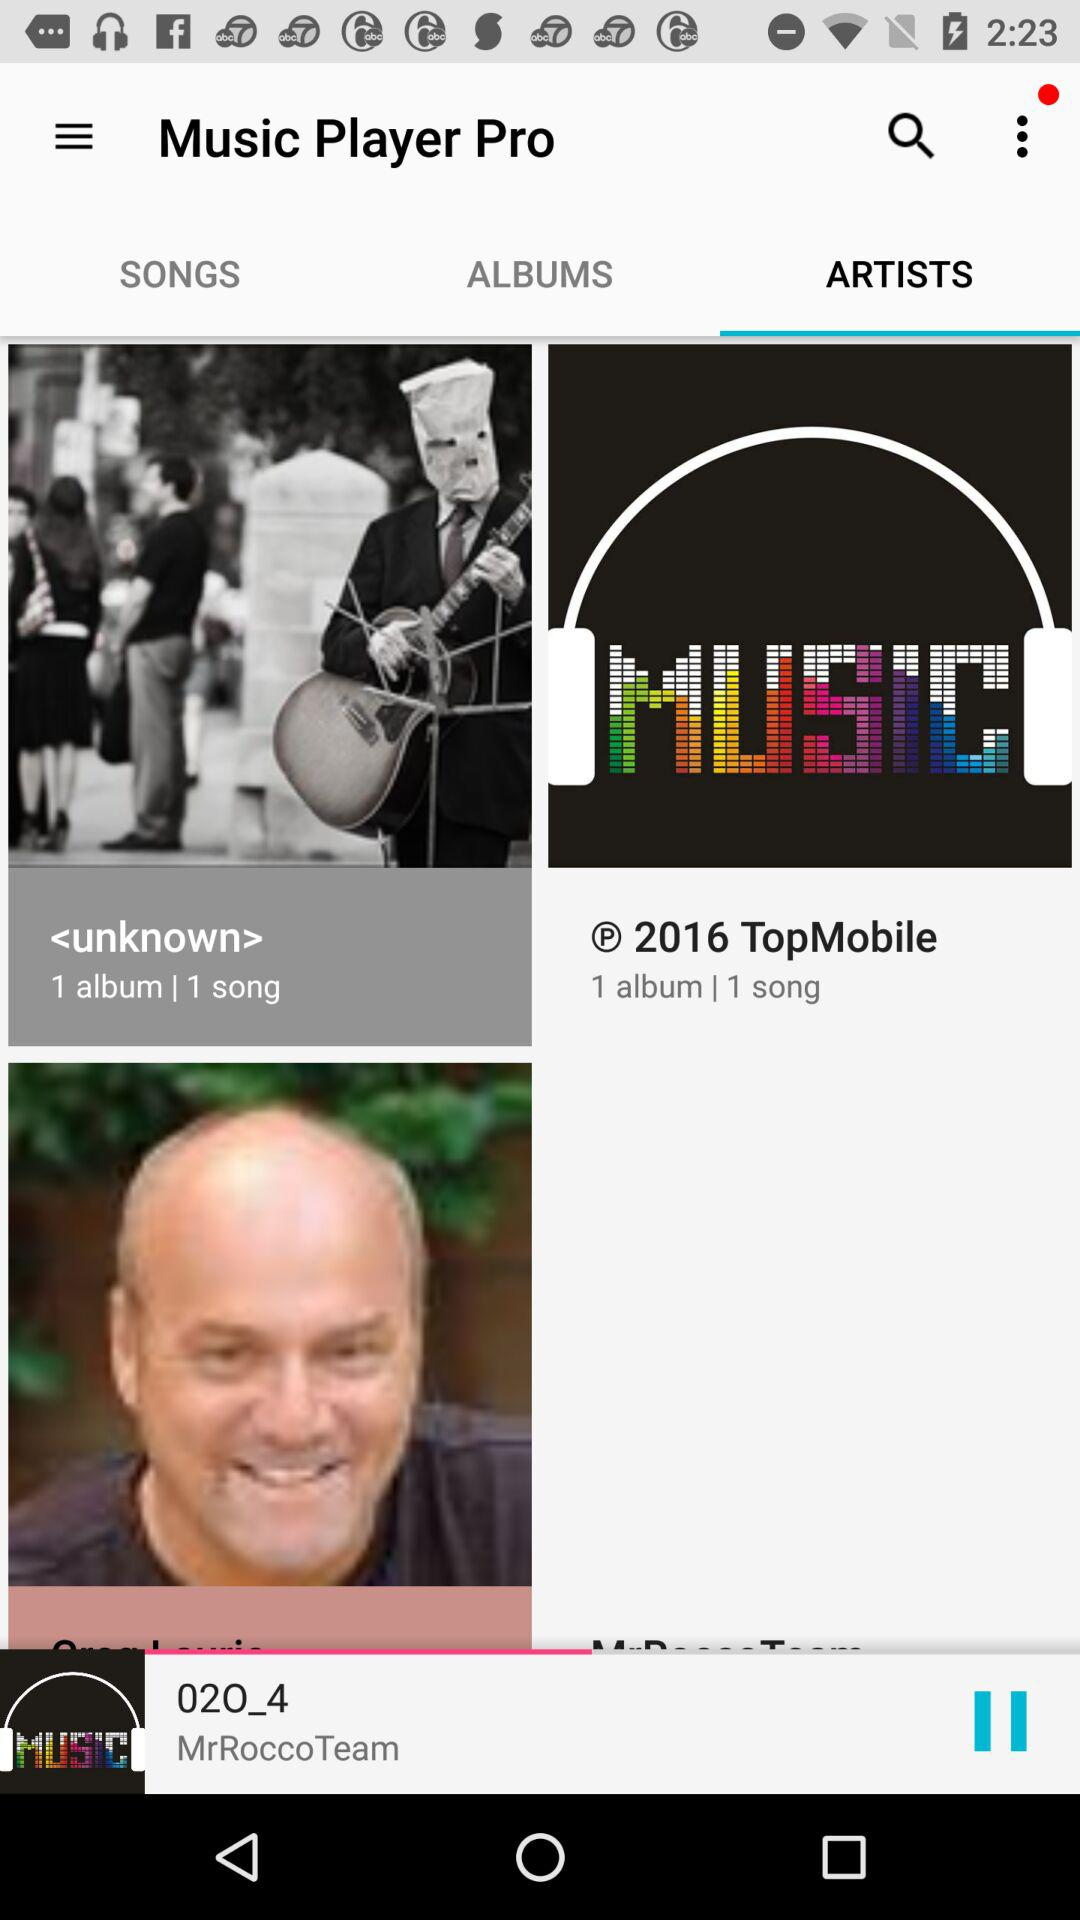Which tab is selected? The selected tab is "ARTISTS". 